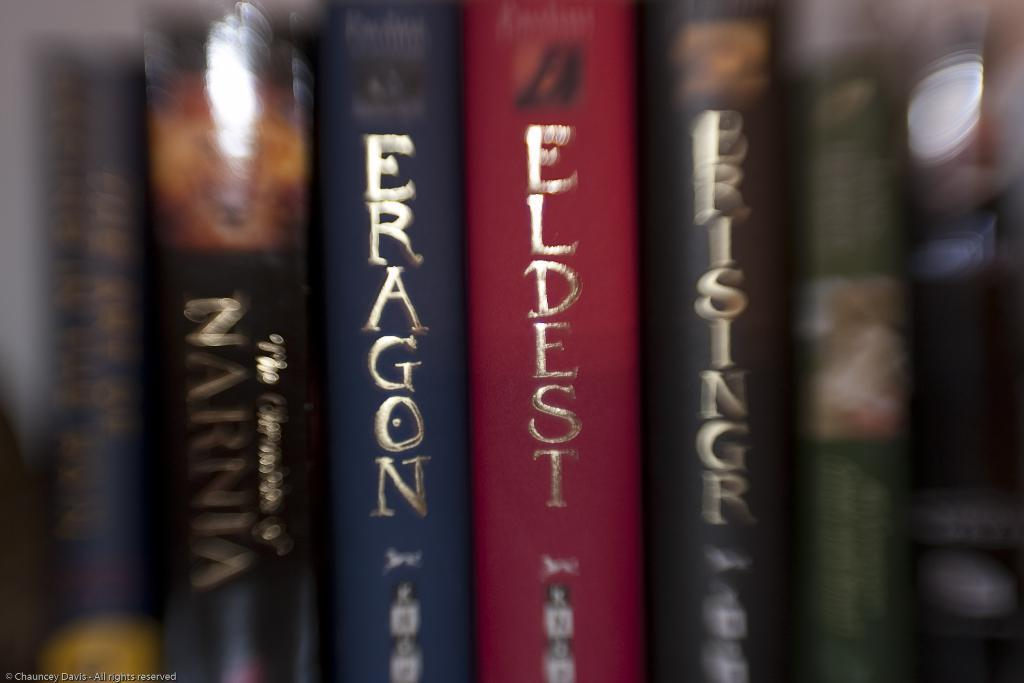<image>
Create a compact narrative representing the image presented. A row of books are labeled Fragon, Eldest, and more. 